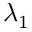<formula> <loc_0><loc_0><loc_500><loc_500>\lambda _ { 1 }</formula> 